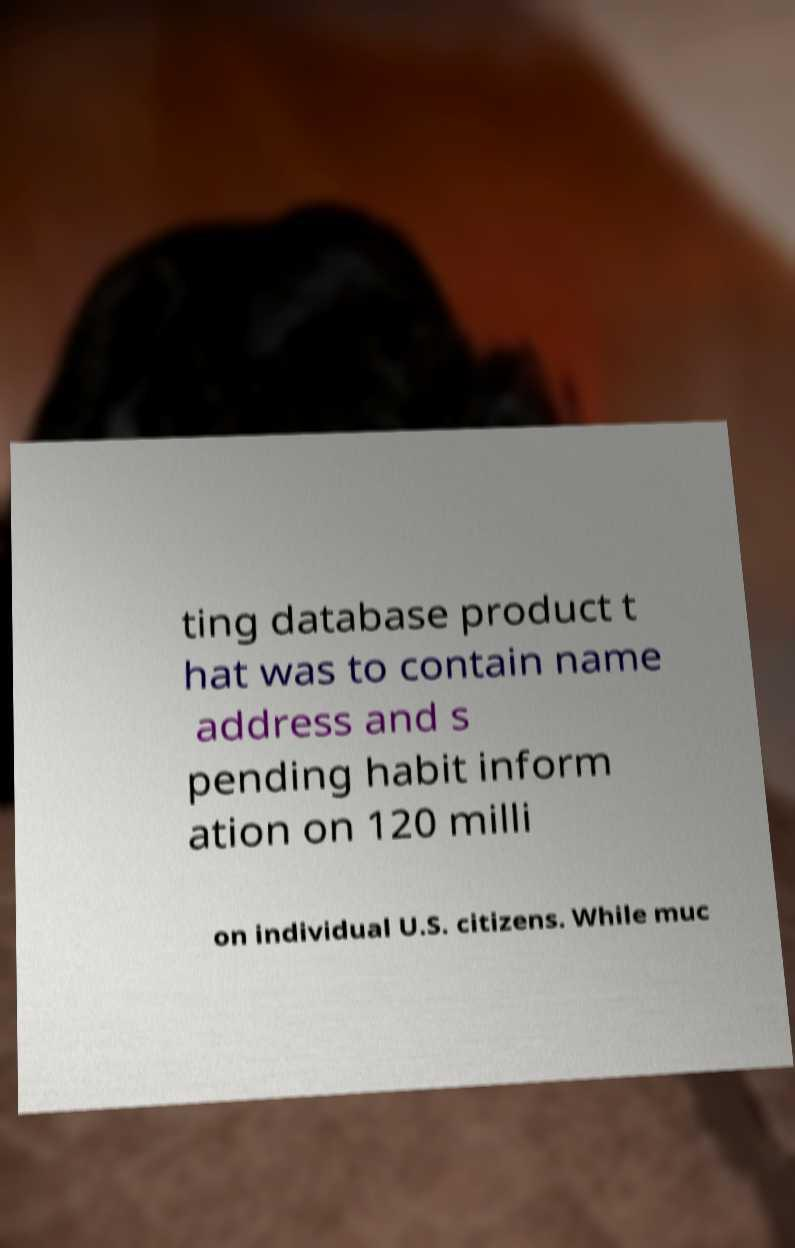Can you accurately transcribe the text from the provided image for me? ting database product t hat was to contain name address and s pending habit inform ation on 120 milli on individual U.S. citizens. While muc 